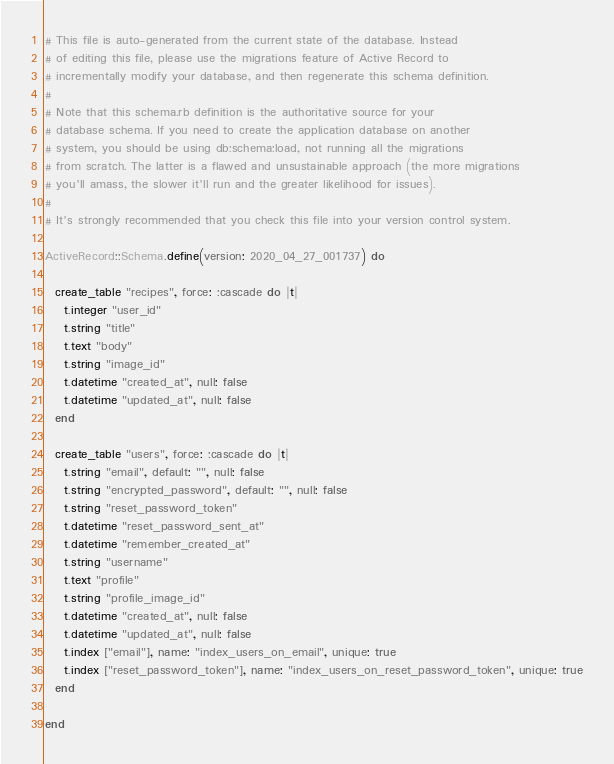Convert code to text. <code><loc_0><loc_0><loc_500><loc_500><_Ruby_># This file is auto-generated from the current state of the database. Instead
# of editing this file, please use the migrations feature of Active Record to
# incrementally modify your database, and then regenerate this schema definition.
#
# Note that this schema.rb definition is the authoritative source for your
# database schema. If you need to create the application database on another
# system, you should be using db:schema:load, not running all the migrations
# from scratch. The latter is a flawed and unsustainable approach (the more migrations
# you'll amass, the slower it'll run and the greater likelihood for issues).
#
# It's strongly recommended that you check this file into your version control system.

ActiveRecord::Schema.define(version: 2020_04_27_001737) do

  create_table "recipes", force: :cascade do |t|
    t.integer "user_id"
    t.string "title"
    t.text "body"
    t.string "image_id"
    t.datetime "created_at", null: false
    t.datetime "updated_at", null: false
  end

  create_table "users", force: :cascade do |t|
    t.string "email", default: "", null: false
    t.string "encrypted_password", default: "", null: false
    t.string "reset_password_token"
    t.datetime "reset_password_sent_at"
    t.datetime "remember_created_at"
    t.string "username"
    t.text "profile"
    t.string "profile_image_id"
    t.datetime "created_at", null: false
    t.datetime "updated_at", null: false
    t.index ["email"], name: "index_users_on_email", unique: true
    t.index ["reset_password_token"], name: "index_users_on_reset_password_token", unique: true
  end

end
</code> 